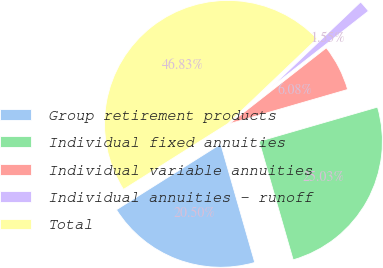Convert chart. <chart><loc_0><loc_0><loc_500><loc_500><pie_chart><fcel>Group retirement products<fcel>Individual fixed annuities<fcel>Individual variable annuities<fcel>Individual annuities - runoff<fcel>Total<nl><fcel>20.5%<fcel>25.03%<fcel>6.08%<fcel>1.55%<fcel>46.83%<nl></chart> 